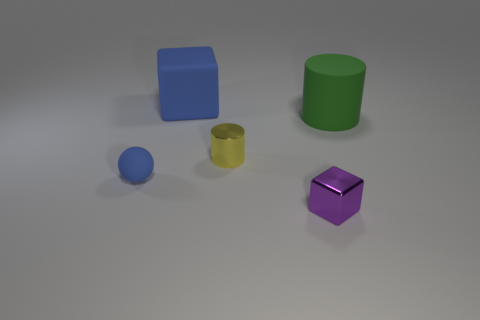Does this image depict a real-life scenario or is it computer-generated? The image appears to be computer-generated. The shadows and lighting look artificial, and the objects have a matte, uniform texture that is typical of rendered images. 